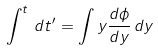<formula> <loc_0><loc_0><loc_500><loc_500>\int ^ { t } \, d t ^ { \prime } = \int y \frac { d \phi } { d y } \, d y</formula> 